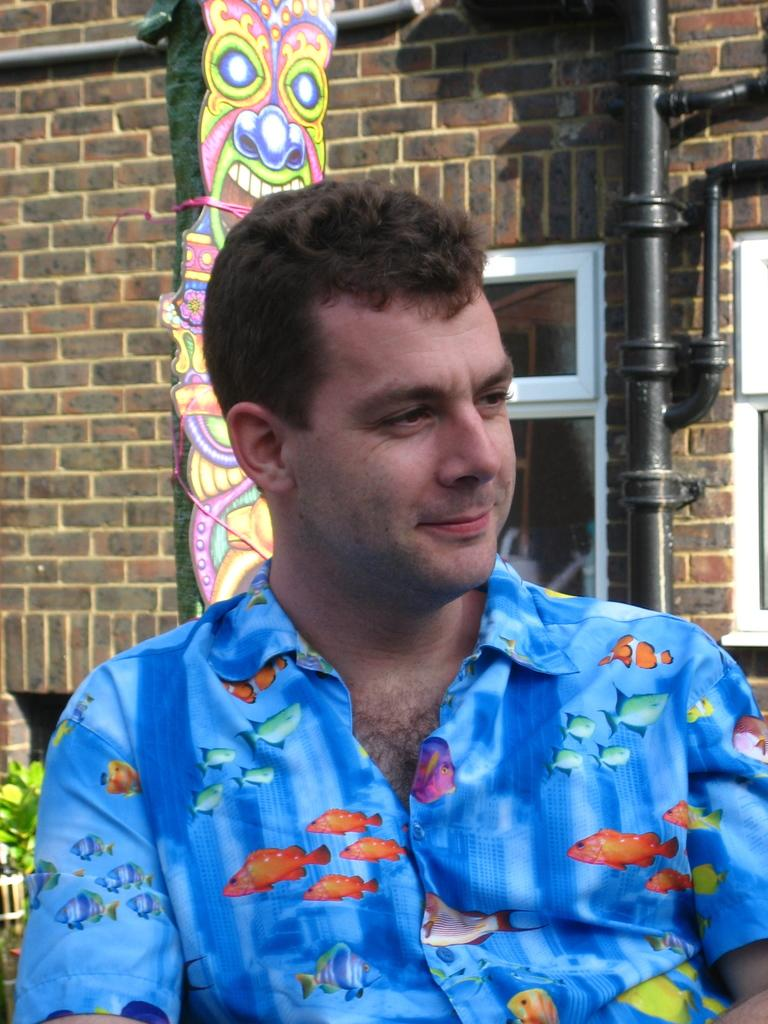What is present in the image? There is a person in the image. What is the person wearing? The person is wearing a blue dress. What can be seen in the background of the image? There is a building in the background of the image. What type of snake is the person holding in the image? There is no snake present in the image; the person is wearing a blue dress and standing in front of a building. 